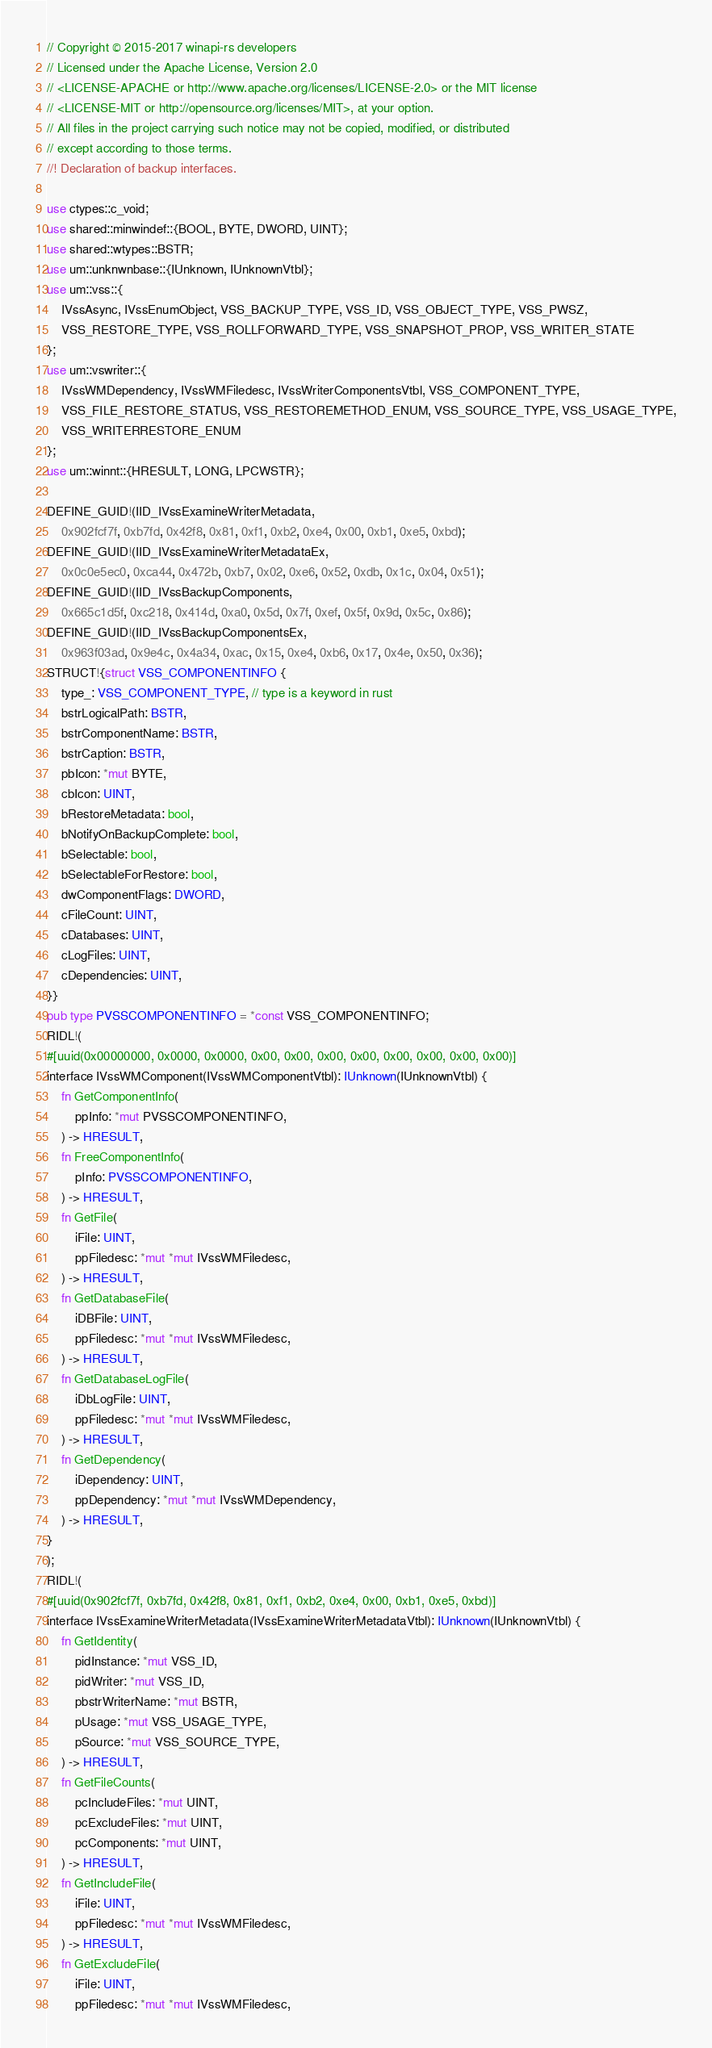Convert code to text. <code><loc_0><loc_0><loc_500><loc_500><_Rust_>// Copyright © 2015-2017 winapi-rs developers
// Licensed under the Apache License, Version 2.0
// <LICENSE-APACHE or http://www.apache.org/licenses/LICENSE-2.0> or the MIT license
// <LICENSE-MIT or http://opensource.org/licenses/MIT>, at your option.
// All files in the project carrying such notice may not be copied, modified, or distributed
// except according to those terms.
//! Declaration of backup interfaces.

use ctypes::c_void;
use shared::minwindef::{BOOL, BYTE, DWORD, UINT};
use shared::wtypes::BSTR;
use um::unknwnbase::{IUnknown, IUnknownVtbl};
use um::vss::{
    IVssAsync, IVssEnumObject, VSS_BACKUP_TYPE, VSS_ID, VSS_OBJECT_TYPE, VSS_PWSZ,
    VSS_RESTORE_TYPE, VSS_ROLLFORWARD_TYPE, VSS_SNAPSHOT_PROP, VSS_WRITER_STATE
};
use um::vswriter::{
    IVssWMDependency, IVssWMFiledesc, IVssWriterComponentsVtbl, VSS_COMPONENT_TYPE,
    VSS_FILE_RESTORE_STATUS, VSS_RESTOREMETHOD_ENUM, VSS_SOURCE_TYPE, VSS_USAGE_TYPE,
    VSS_WRITERRESTORE_ENUM
};
use um::winnt::{HRESULT, LONG, LPCWSTR};

DEFINE_GUID!(IID_IVssExamineWriterMetadata,
    0x902fcf7f, 0xb7fd, 0x42f8, 0x81, 0xf1, 0xb2, 0xe4, 0x00, 0xb1, 0xe5, 0xbd);
DEFINE_GUID!(IID_IVssExamineWriterMetadataEx,
    0x0c0e5ec0, 0xca44, 0x472b, 0xb7, 0x02, 0xe6, 0x52, 0xdb, 0x1c, 0x04, 0x51);
DEFINE_GUID!(IID_IVssBackupComponents,
    0x665c1d5f, 0xc218, 0x414d, 0xa0, 0x5d, 0x7f, 0xef, 0x5f, 0x9d, 0x5c, 0x86);
DEFINE_GUID!(IID_IVssBackupComponentsEx,
    0x963f03ad, 0x9e4c, 0x4a34, 0xac, 0x15, 0xe4, 0xb6, 0x17, 0x4e, 0x50, 0x36);
STRUCT!{struct VSS_COMPONENTINFO {
    type_: VSS_COMPONENT_TYPE, // type is a keyword in rust
    bstrLogicalPath: BSTR,
    bstrComponentName: BSTR,
    bstrCaption: BSTR,
    pbIcon: *mut BYTE,
    cbIcon: UINT,
    bRestoreMetadata: bool,
    bNotifyOnBackupComplete: bool,
    bSelectable: bool,
    bSelectableForRestore: bool,
    dwComponentFlags: DWORD,
    cFileCount: UINT,
    cDatabases: UINT,
    cLogFiles: UINT,
    cDependencies: UINT,
}}
pub type PVSSCOMPONENTINFO = *const VSS_COMPONENTINFO;
RIDL!(
#[uuid(0x00000000, 0x0000, 0x0000, 0x00, 0x00, 0x00, 0x00, 0x00, 0x00, 0x00, 0x00)]
interface IVssWMComponent(IVssWMComponentVtbl): IUnknown(IUnknownVtbl) {
    fn GetComponentInfo(
        ppInfo: *mut PVSSCOMPONENTINFO,
    ) -> HRESULT,
    fn FreeComponentInfo(
        pInfo: PVSSCOMPONENTINFO,
    ) -> HRESULT,
    fn GetFile(
        iFile: UINT,
        ppFiledesc: *mut *mut IVssWMFiledesc,
    ) -> HRESULT,
    fn GetDatabaseFile(
        iDBFile: UINT,
        ppFiledesc: *mut *mut IVssWMFiledesc,
    ) -> HRESULT,
    fn GetDatabaseLogFile(
        iDbLogFile: UINT,
        ppFiledesc: *mut *mut IVssWMFiledesc,
    ) -> HRESULT,
    fn GetDependency(
        iDependency: UINT,
        ppDependency: *mut *mut IVssWMDependency,
    ) -> HRESULT,
}
);
RIDL!(
#[uuid(0x902fcf7f, 0xb7fd, 0x42f8, 0x81, 0xf1, 0xb2, 0xe4, 0x00, 0xb1, 0xe5, 0xbd)]
interface IVssExamineWriterMetadata(IVssExamineWriterMetadataVtbl): IUnknown(IUnknownVtbl) {
    fn GetIdentity(
        pidInstance: *mut VSS_ID,
        pidWriter: *mut VSS_ID,
        pbstrWriterName: *mut BSTR,
        pUsage: *mut VSS_USAGE_TYPE,
        pSource: *mut VSS_SOURCE_TYPE,
    ) -> HRESULT,
    fn GetFileCounts(
        pcIncludeFiles: *mut UINT,
        pcExcludeFiles: *mut UINT,
        pcComponents: *mut UINT,
    ) -> HRESULT,
    fn GetIncludeFile(
        iFile: UINT,
        ppFiledesc: *mut *mut IVssWMFiledesc,
    ) -> HRESULT,
    fn GetExcludeFile(
        iFile: UINT,
        ppFiledesc: *mut *mut IVssWMFiledesc,</code> 